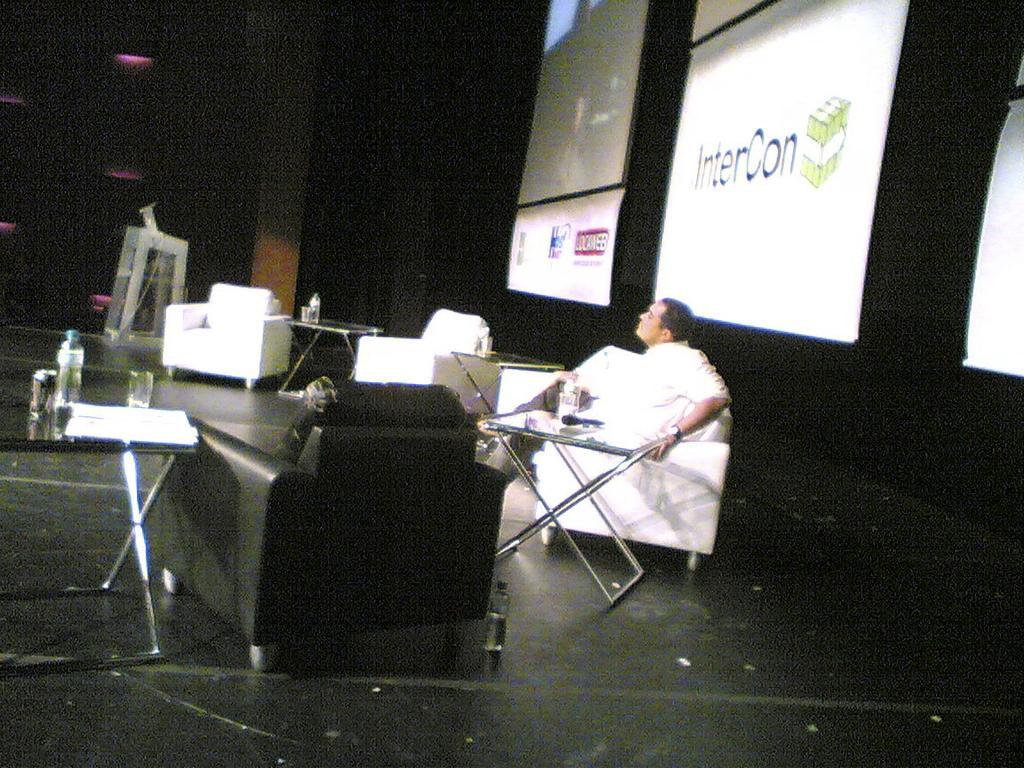Could you give a brief overview of what you see in this image? In the center we can see one person sitting on the chair. In front there is a table,on table we can see remote. On the left again there is one table,chair. In the background there is a wall,screen,sofa,table,pillar and lights. 